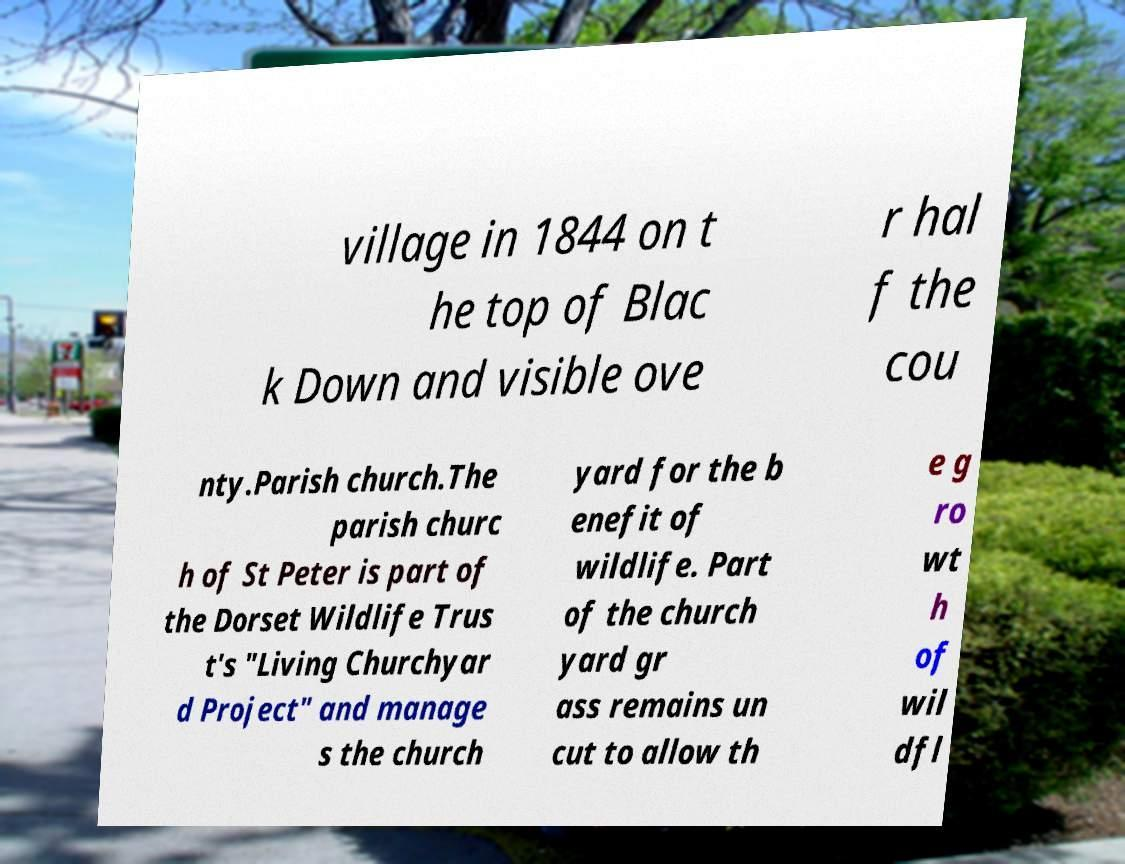For documentation purposes, I need the text within this image transcribed. Could you provide that? village in 1844 on t he top of Blac k Down and visible ove r hal f the cou nty.Parish church.The parish churc h of St Peter is part of the Dorset Wildlife Trus t's "Living Churchyar d Project" and manage s the church yard for the b enefit of wildlife. Part of the church yard gr ass remains un cut to allow th e g ro wt h of wil dfl 